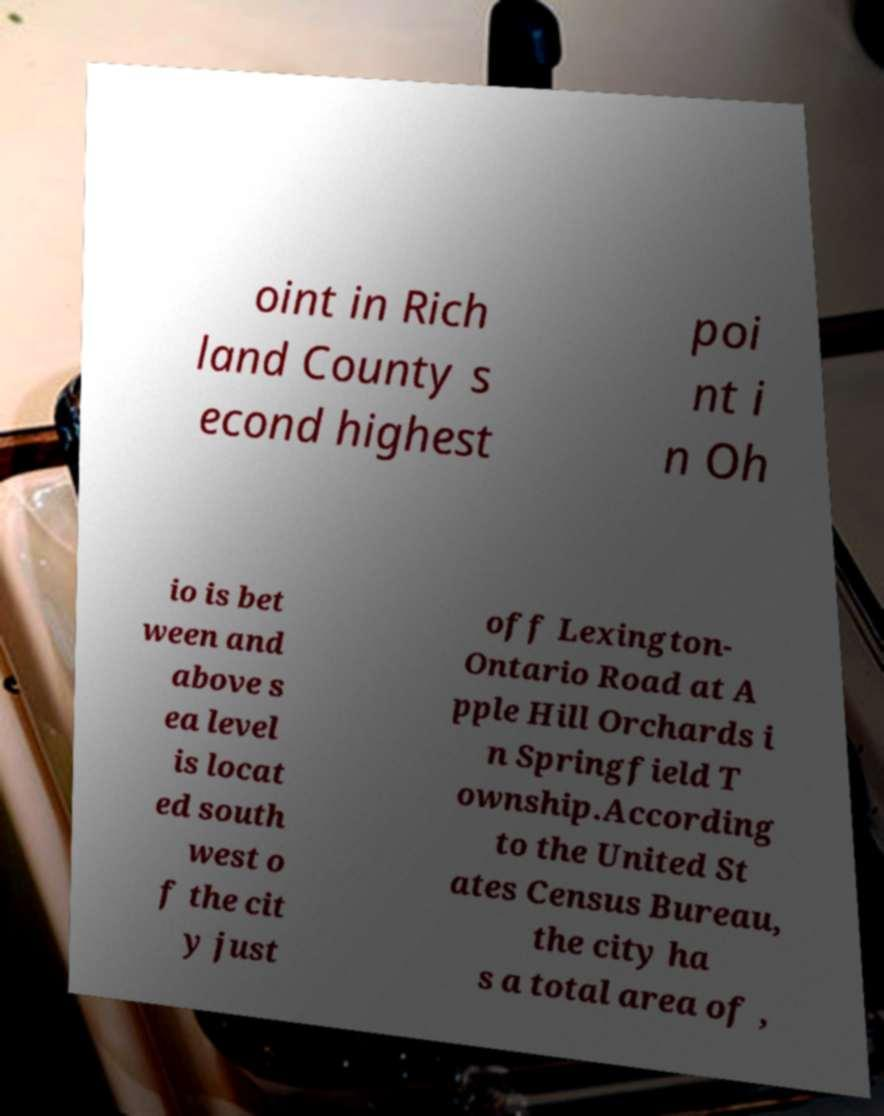For documentation purposes, I need the text within this image transcribed. Could you provide that? oint in Rich land County s econd highest poi nt i n Oh io is bet ween and above s ea level is locat ed south west o f the cit y just off Lexington- Ontario Road at A pple Hill Orchards i n Springfield T ownship.According to the United St ates Census Bureau, the city ha s a total area of , 